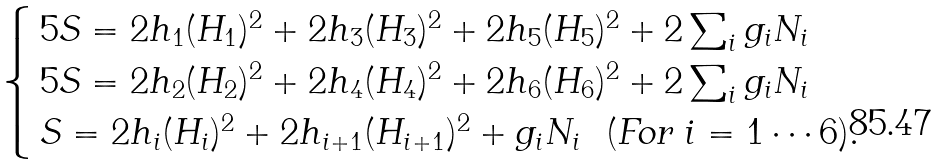<formula> <loc_0><loc_0><loc_500><loc_500>\begin{cases} \, 5 S = 2 h _ { 1 } ( H _ { 1 } ) ^ { 2 } + 2 h _ { 3 } ( H _ { 3 } ) ^ { 2 } + 2 h _ { 5 } ( H _ { 5 } ) ^ { 2 } + 2 \sum _ { i } g _ { i } N _ { i } \\ \, 5 S = 2 h _ { 2 } ( H _ { 2 } ) ^ { 2 } + 2 h _ { 4 } ( H _ { 4 } ) ^ { 2 } + 2 h _ { 6 } ( H _ { 6 } ) ^ { 2 } + 2 \sum _ { i } g _ { i } N _ { i } \\ \, S = 2 h _ { i } ( H _ { i } ) ^ { 2 } + 2 h _ { i + 1 } ( H _ { i + 1 } ) ^ { 2 } + g _ { i } N _ { i } \ \ ( \text {For} \ i = 1 \cdots 6 ) . \end{cases}</formula> 